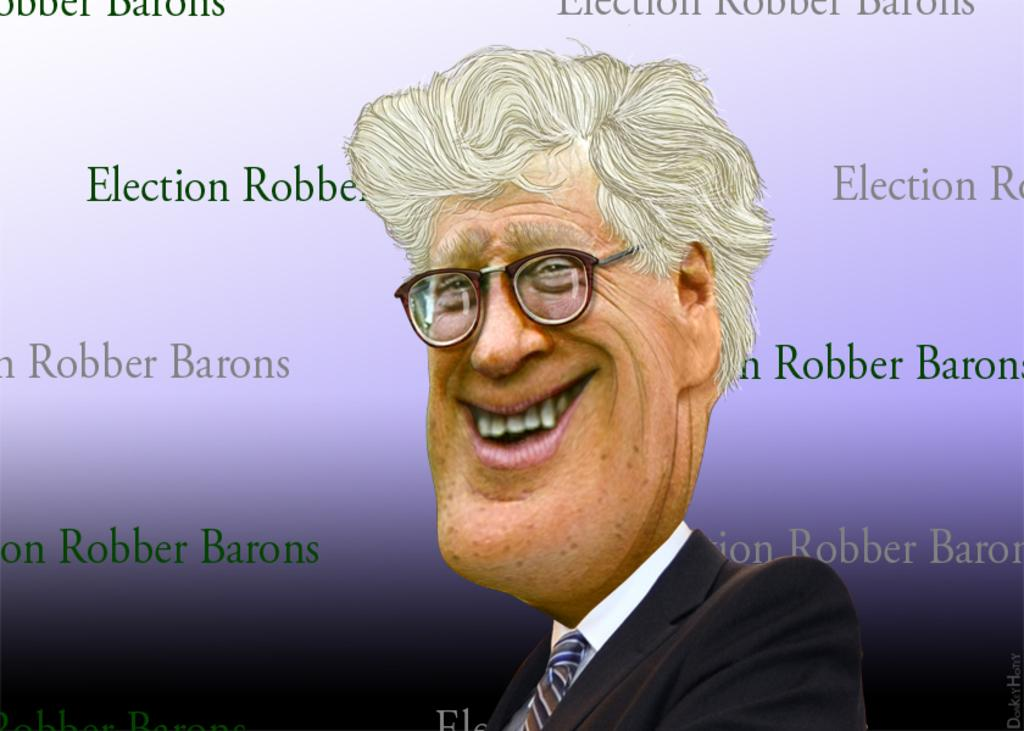What is the main subject of the image? There is a cartoon of a man in the center of the image. What else can be found in the image besides the cartoon? There is text in the image. What color is the stocking worn by the man in the image? There is no stocking visible in the image, as it features a cartoon of a man without any clothing details. 